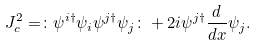Convert formula to latex. <formula><loc_0><loc_0><loc_500><loc_500>J _ { c } ^ { 2 } = \colon \psi ^ { i \dagger } \psi _ { i } \psi ^ { j \dagger } \psi _ { j } \colon + 2 i \psi ^ { j \dagger } \frac { d } { d x } \psi _ { j } .</formula> 